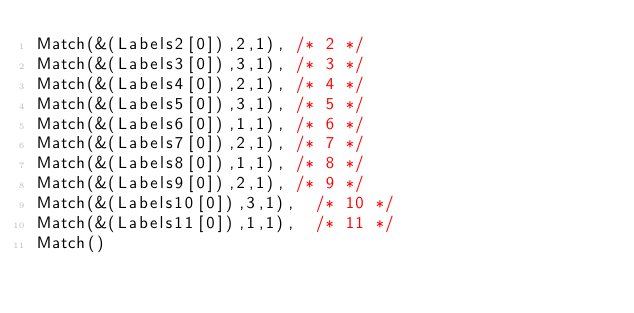Convert code to text. <code><loc_0><loc_0><loc_500><loc_500><_C++_>Match(&(Labels2[0]),2,1),	/* 2 */
Match(&(Labels3[0]),3,1),	/* 3 */
Match(&(Labels4[0]),2,1),	/* 4 */
Match(&(Labels5[0]),3,1),	/* 5 */
Match(&(Labels6[0]),1,1),	/* 6 */
Match(&(Labels7[0]),2,1),	/* 7 */
Match(&(Labels8[0]),1,1),	/* 8 */
Match(&(Labels9[0]),2,1),	/* 9 */
Match(&(Labels10[0]),3,1),	/* 10 */
Match(&(Labels11[0]),1,1),	/* 11 */
Match()
</code> 